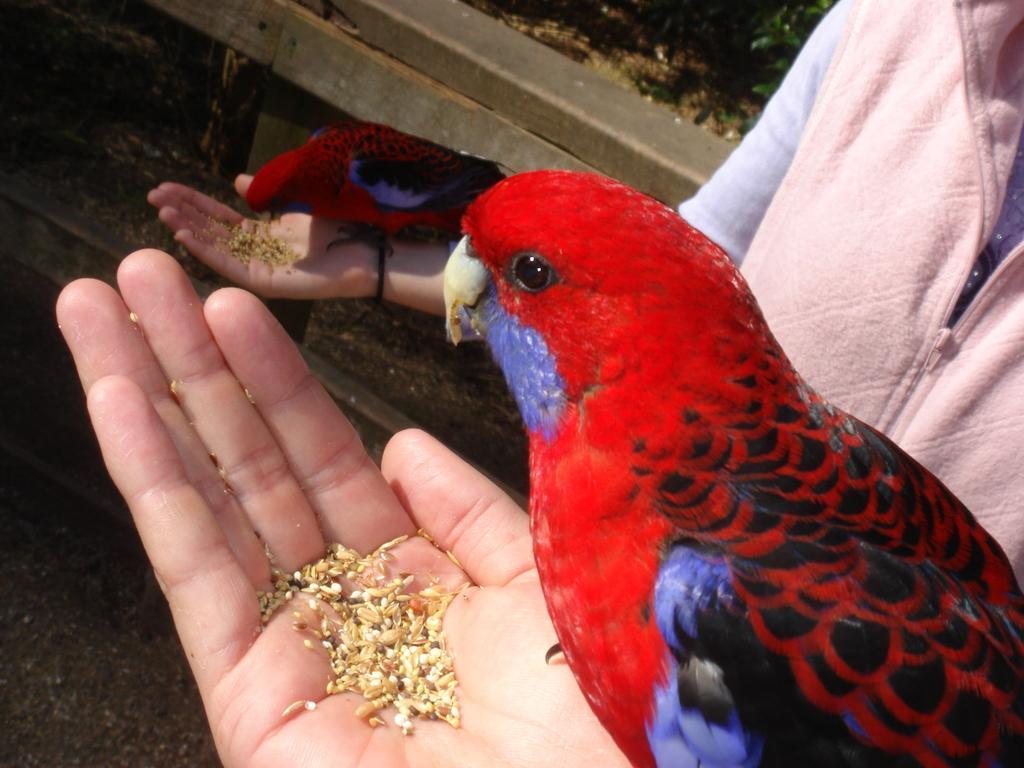Could you give a brief overview of what you see in this image? In this image there are two red colour parrots which are eating the food which is in the hand. On the right side there is a person who is feeding the parrots. 